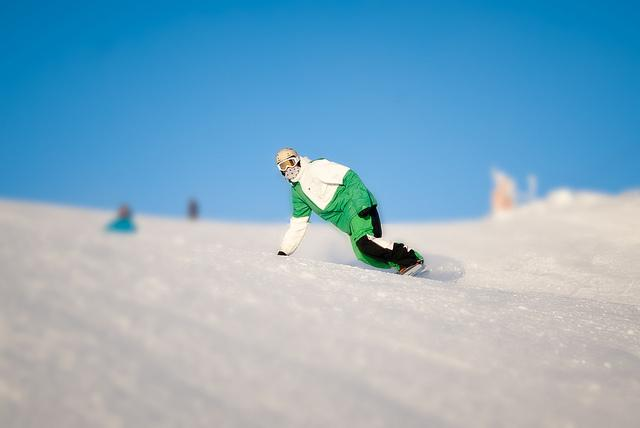The item the person is wearing on their face looks like what? goggles 